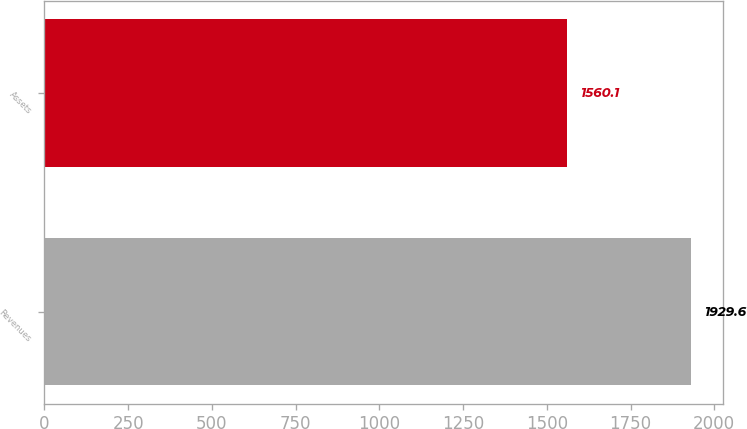Convert chart to OTSL. <chart><loc_0><loc_0><loc_500><loc_500><bar_chart><fcel>Revenues<fcel>Assets<nl><fcel>1929.6<fcel>1560.1<nl></chart> 